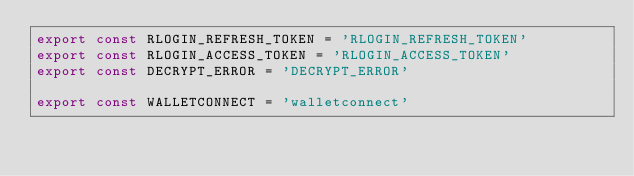<code> <loc_0><loc_0><loc_500><loc_500><_TypeScript_>export const RLOGIN_REFRESH_TOKEN = 'RLOGIN_REFRESH_TOKEN'
export const RLOGIN_ACCESS_TOKEN = 'RLOGIN_ACCESS_TOKEN'
export const DECRYPT_ERROR = 'DECRYPT_ERROR'

export const WALLETCONNECT = 'walletconnect'
</code> 